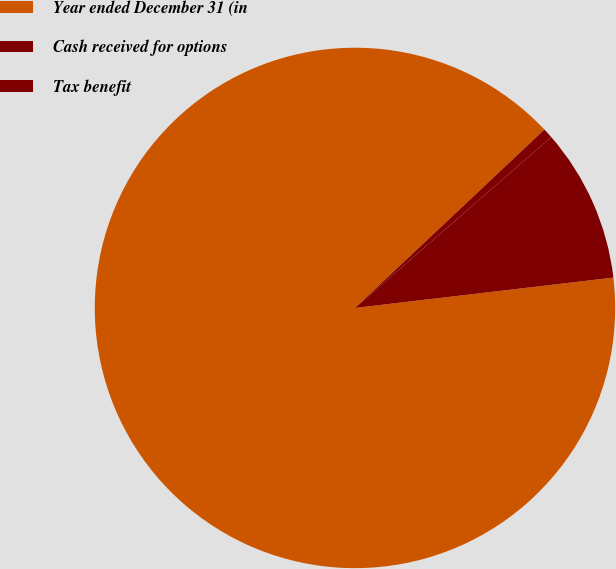Convert chart. <chart><loc_0><loc_0><loc_500><loc_500><pie_chart><fcel>Year ended December 31 (in<fcel>Cash received for options<fcel>Tax benefit<nl><fcel>89.83%<fcel>0.62%<fcel>9.54%<nl></chart> 